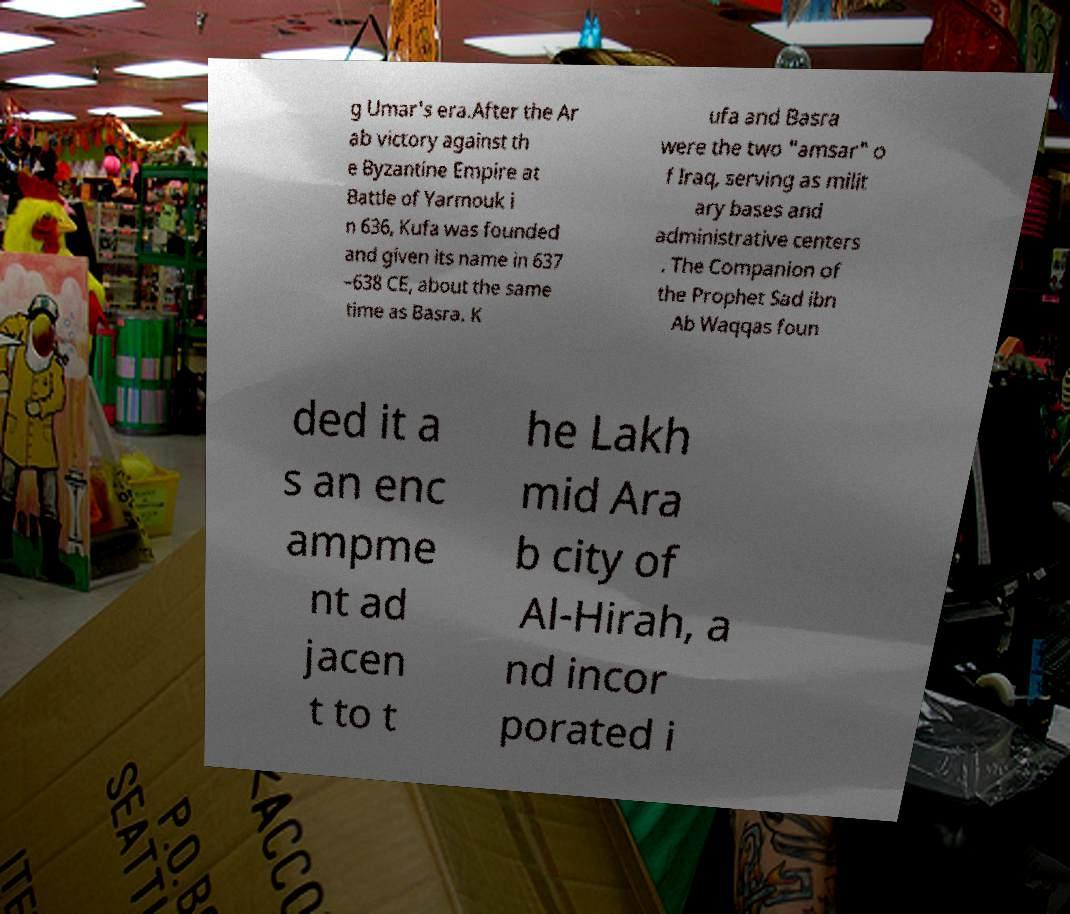I need the written content from this picture converted into text. Can you do that? g Umar's era.After the Ar ab victory against th e Byzantine Empire at Battle of Yarmouk i n 636, Kufa was founded and given its name in 637 –638 CE, about the same time as Basra. K ufa and Basra were the two "amsar" o f Iraq, serving as milit ary bases and administrative centers . The Companion of the Prophet Sad ibn Ab Waqqas foun ded it a s an enc ampme nt ad jacen t to t he Lakh mid Ara b city of Al-Hirah, a nd incor porated i 